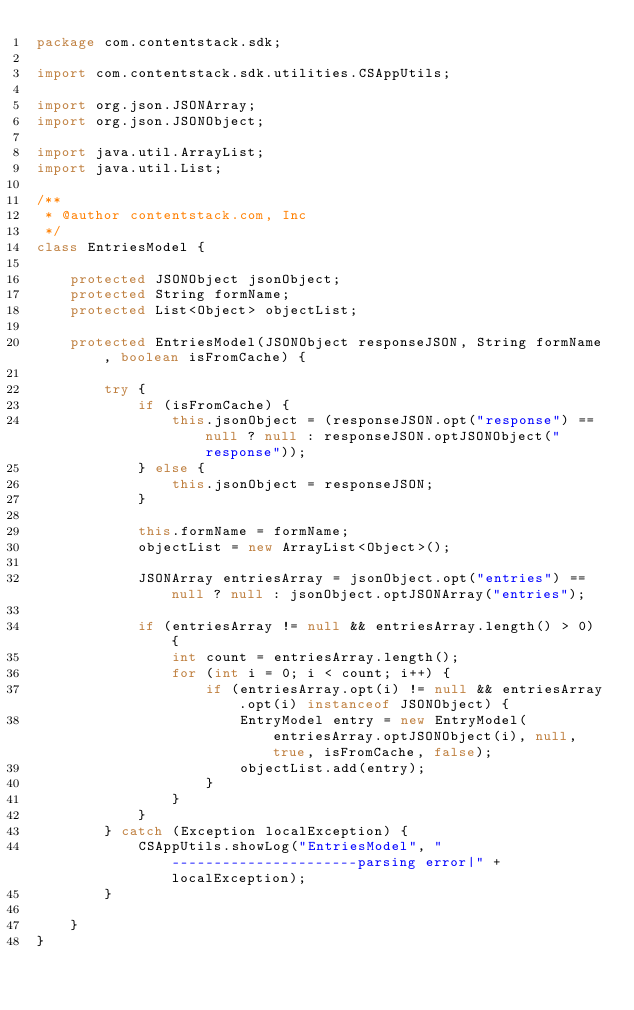<code> <loc_0><loc_0><loc_500><loc_500><_Java_>package com.contentstack.sdk;

import com.contentstack.sdk.utilities.CSAppUtils;

import org.json.JSONArray;
import org.json.JSONObject;

import java.util.ArrayList;
import java.util.List;

/**
 * @author contentstack.com, Inc
 */
class EntriesModel {

    protected JSONObject jsonObject;
    protected String formName;
    protected List<Object> objectList;

    protected EntriesModel(JSONObject responseJSON, String formName, boolean isFromCache) {

        try {
            if (isFromCache) {
                this.jsonObject = (responseJSON.opt("response") == null ? null : responseJSON.optJSONObject("response"));
            } else {
                this.jsonObject = responseJSON;
            }

            this.formName = formName;
            objectList = new ArrayList<Object>();

            JSONArray entriesArray = jsonObject.opt("entries") == null ? null : jsonObject.optJSONArray("entries");

            if (entriesArray != null && entriesArray.length() > 0) {
                int count = entriesArray.length();
                for (int i = 0; i < count; i++) {
                    if (entriesArray.opt(i) != null && entriesArray.opt(i) instanceof JSONObject) {
                        EntryModel entry = new EntryModel(entriesArray.optJSONObject(i), null, true, isFromCache, false);
                        objectList.add(entry);
                    }
                }
            }
        } catch (Exception localException) {
            CSAppUtils.showLog("EntriesModel", "----------------------parsing error|" + localException);
        }

    }
}
</code> 